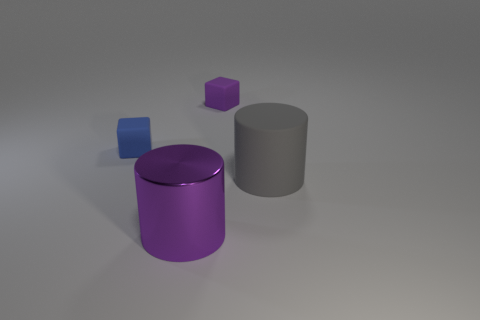Add 3 purple metal cylinders. How many objects exist? 7 Subtract 0 cyan balls. How many objects are left? 4 Subtract all small brown metal cubes. Subtract all large gray matte things. How many objects are left? 3 Add 3 purple cylinders. How many purple cylinders are left? 4 Add 1 large rubber objects. How many large rubber objects exist? 2 